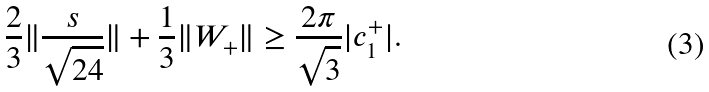<formula> <loc_0><loc_0><loc_500><loc_500>\frac { 2 } { 3 } \| \frac { s } { \sqrt { 2 4 } } \| + { \frac { 1 } { 3 } } \| W _ { + } \| \geq \frac { 2 \pi } { \sqrt { 3 } } | c _ { 1 } ^ { + } | .</formula> 